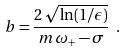Convert formula to latex. <formula><loc_0><loc_0><loc_500><loc_500>b = \frac { 2 \, \sqrt { \ln ( 1 / \epsilon ) } } { m \, \omega _ { + } - \sigma } \ .</formula> 